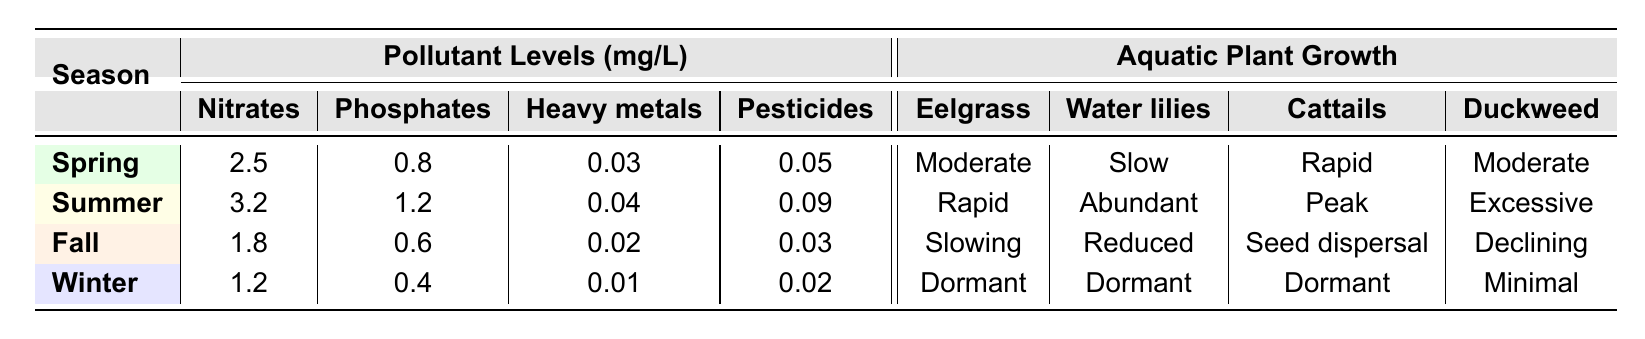What is the Nitrate level in Summer? The table indicates that in Summer, the Nitrate level is listed as 3.2 mg/L.
Answer: 3.2 mg/L Which season has the highest levels of Phosphates? By examining the table, the Summer season shows the highest Phosphate level at 1.2 mg/L compared to other seasons.
Answer: Summer Is there a seasonal pattern in the growth of Eelgrass? Observing the data, Eelgrass shows rapid growth in Summer, moderate growth in Spring, slowing growth in Fall, and is dormant in Winter, indicating a seasonal pattern linked to warmer months.
Answer: Yes What is the combined total of Nitrates and Phosphates in Fall? According to the table, Nitrate levels are 1.8 mg/L and Phosphate levels are 0.6 mg/L for Fall. Adding these values gives a total of 1.8 + 0.6 = 2.4 mg/L.
Answer: 2.4 mg/L Which aquatic plant shows excessive growth in Summer? Referring to the table, Duckweed is noted for "Excessive growth" during the Summer season.
Answer: Duckweed Does the level of Heavy metals decrease from Spring to Winter? The Heavy metal levels are 0.03 mg/L in Spring, 0.04 mg/L in Summer, 0.02 mg/L in Fall, and decrease to 0.01 mg/L in Winter, confirming a decrease from Spring to Winter.
Answer: Yes What is the growth status of Water lilies in Winter? The table shows that Water lilies are classified as "Dormant" in Winter.
Answer: Dormant Calculate the difference in Pesticide levels between Spring and Spring. In Spring, the Pesticide level is 0.05 mg/L, and it remains the same in Spring, so the difference is 0.05 - 0.05 = 0 mg/L.
Answer: 0 mg/L What season indicates peak growth for Cattails? The table states that Cattails demonstrate "Peak growth" during the Summer season.
Answer: Summer Is there a decrease in Duckweed growth from Spring to Fall? Duckweed growth is "Moderate" in Spring and "Declining" in Fall, indicating a decrease in growth from Spring to Fall.
Answer: Yes 